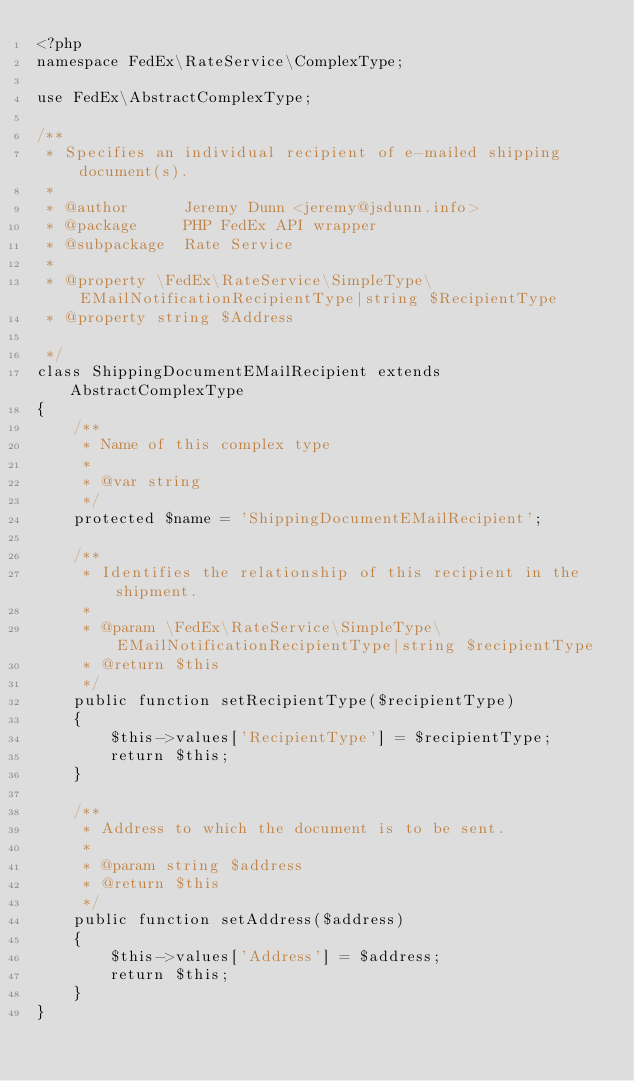Convert code to text. <code><loc_0><loc_0><loc_500><loc_500><_PHP_><?php
namespace FedEx\RateService\ComplexType;

use FedEx\AbstractComplexType;

/**
 * Specifies an individual recipient of e-mailed shipping document(s).
 *
 * @author      Jeremy Dunn <jeremy@jsdunn.info>
 * @package     PHP FedEx API wrapper
 * @subpackage  Rate Service
 *
 * @property \FedEx\RateService\SimpleType\EMailNotificationRecipientType|string $RecipientType
 * @property string $Address

 */
class ShippingDocumentEMailRecipient extends AbstractComplexType
{
    /**
     * Name of this complex type
     *
     * @var string
     */
    protected $name = 'ShippingDocumentEMailRecipient';

    /**
     * Identifies the relationship of this recipient in the shipment.
     *
     * @param \FedEx\RateService\SimpleType\EMailNotificationRecipientType|string $recipientType
     * @return $this
     */
    public function setRecipientType($recipientType)
    {
        $this->values['RecipientType'] = $recipientType;
        return $this;
    }

    /**
     * Address to which the document is to be sent.
     *
     * @param string $address
     * @return $this
     */
    public function setAddress($address)
    {
        $this->values['Address'] = $address;
        return $this;
    }
}
</code> 